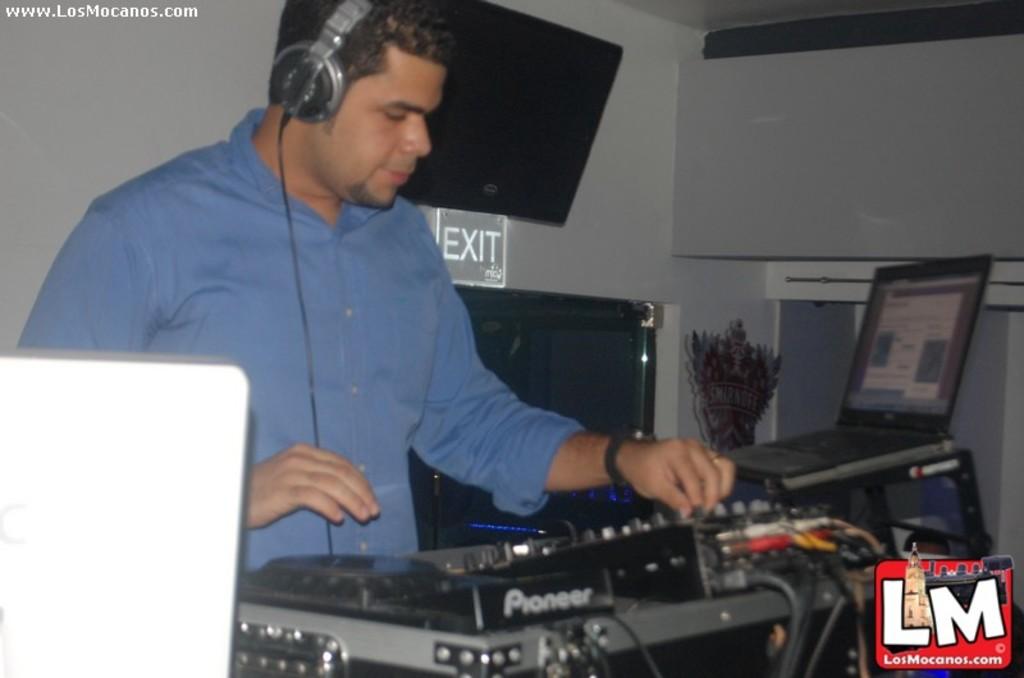What brand of dj equipment is he using?
Offer a very short reply. Pioneer. 